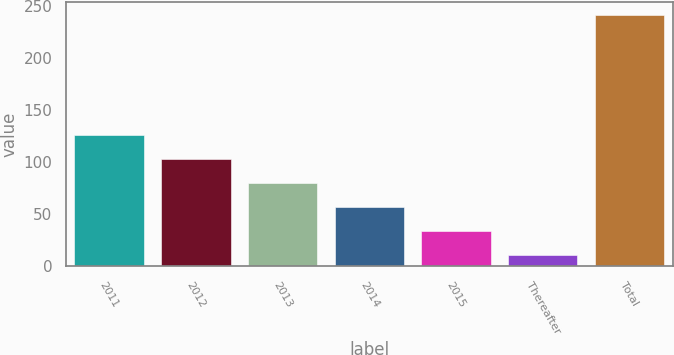<chart> <loc_0><loc_0><loc_500><loc_500><bar_chart><fcel>2011<fcel>2012<fcel>2013<fcel>2014<fcel>2015<fcel>Thereafter<fcel>Total<nl><fcel>126.5<fcel>103.4<fcel>80.3<fcel>57.2<fcel>34.1<fcel>11<fcel>242<nl></chart> 